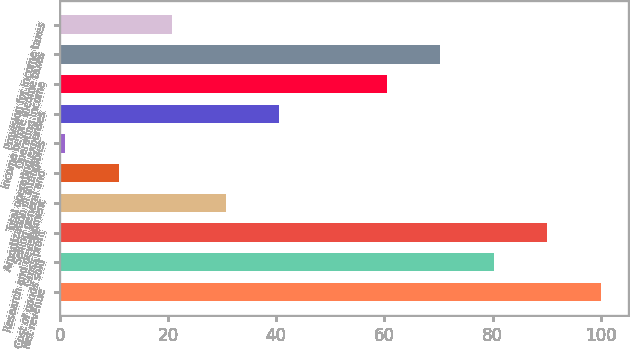<chart> <loc_0><loc_0><loc_500><loc_500><bar_chart><fcel>Net revenue<fcel>Cost of goods sold<fcel>Gross profit<fcel>Research and development<fcel>Selling general and<fcel>Amortization of intangibles<fcel>Total operating expenses<fcel>Operating income<fcel>Income before income taxes<fcel>Provision for income taxes<nl><fcel>100<fcel>80.2<fcel>90.1<fcel>30.7<fcel>10.9<fcel>1<fcel>40.6<fcel>60.4<fcel>70.3<fcel>20.8<nl></chart> 